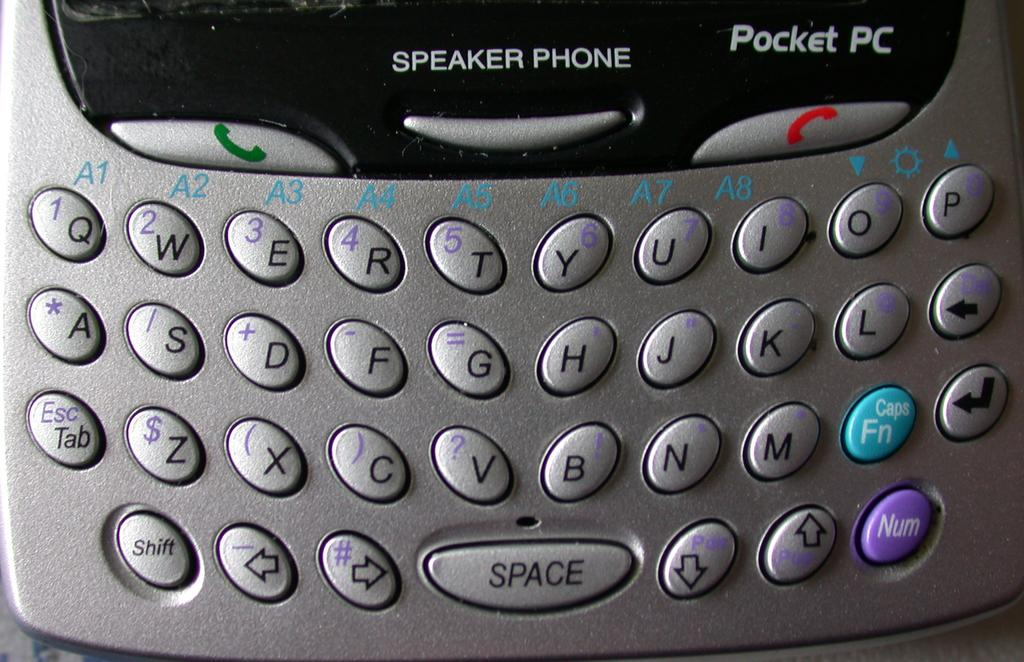<image>
Create a compact narrative representing the image presented. It's an up close look of Pocket PC's keyboard, along with the speaker phone, call, and end call buttons. 